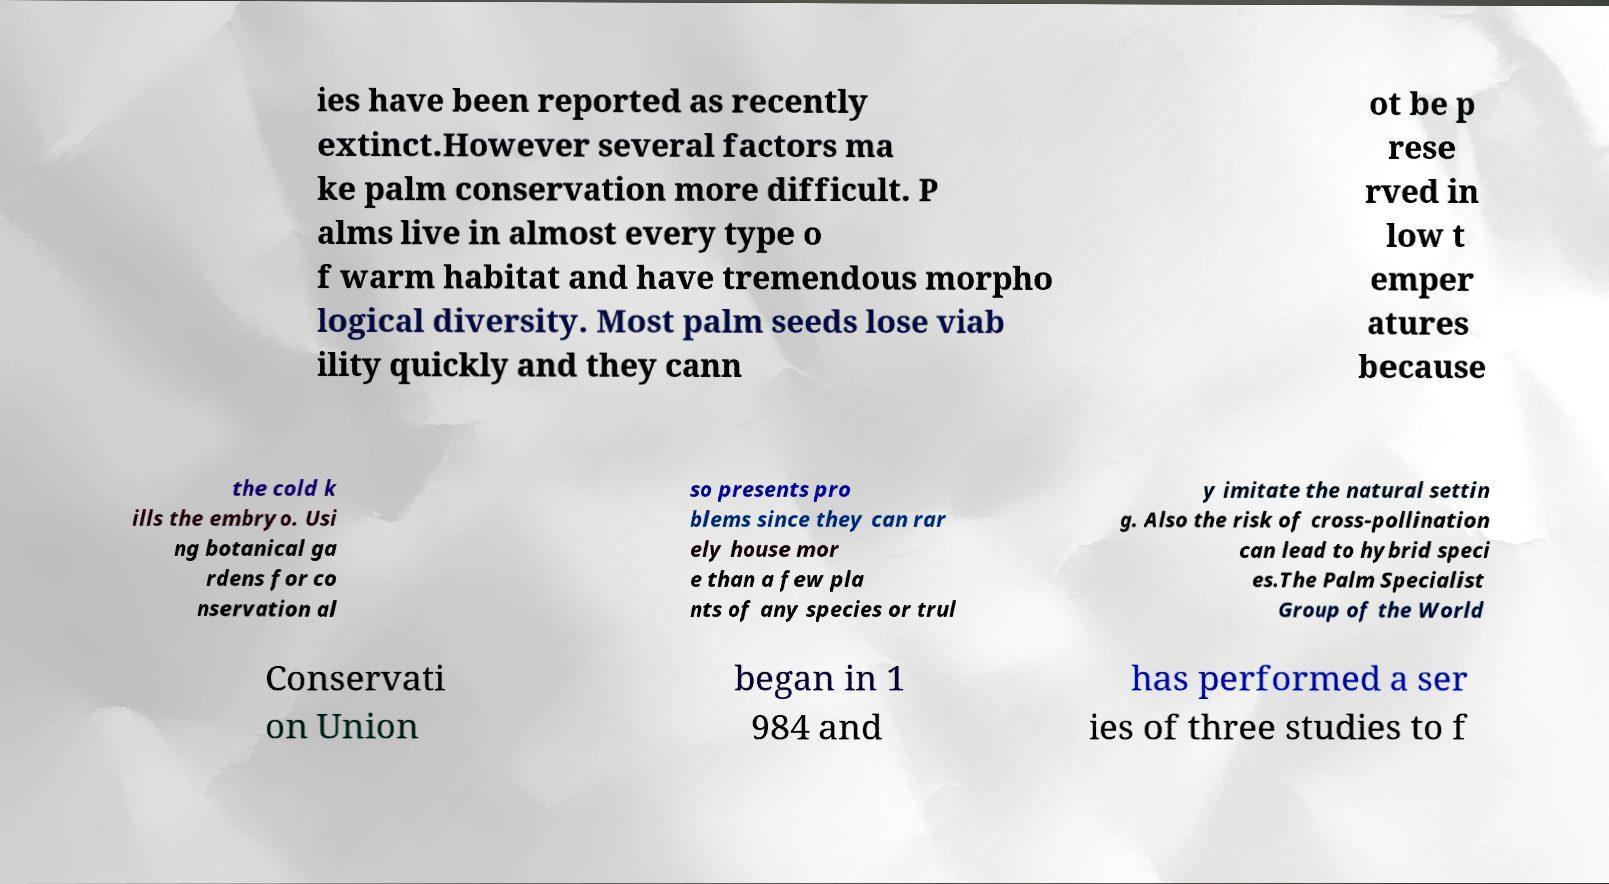Could you extract and type out the text from this image? ies have been reported as recently extinct.However several factors ma ke palm conservation more difficult. P alms live in almost every type o f warm habitat and have tremendous morpho logical diversity. Most palm seeds lose viab ility quickly and they cann ot be p rese rved in low t emper atures because the cold k ills the embryo. Usi ng botanical ga rdens for co nservation al so presents pro blems since they can rar ely house mor e than a few pla nts of any species or trul y imitate the natural settin g. Also the risk of cross-pollination can lead to hybrid speci es.The Palm Specialist Group of the World Conservati on Union began in 1 984 and has performed a ser ies of three studies to f 